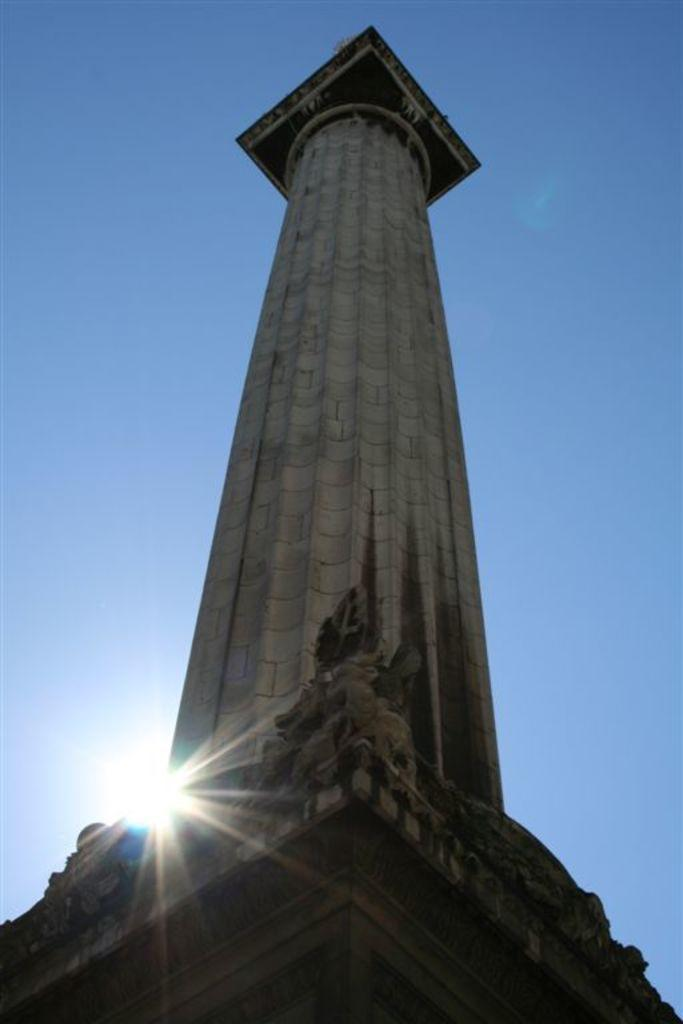What is the main subject of the image? There is a monument in the image. What can be seen in the background of the image? The sky is visible in the image. Can the sun be seen in the image? Yes, the sun is observable in the sky. What type of hammer can be seen falling from the sky in the image? There is no hammer present in the image, and therefore no such event can be observed. 